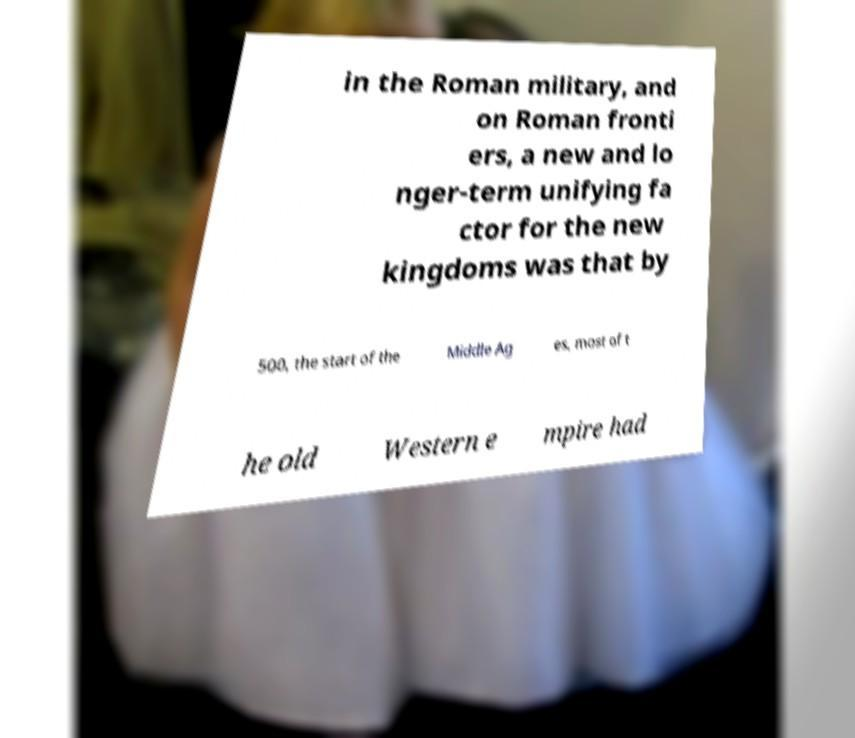Please identify and transcribe the text found in this image. in the Roman military, and on Roman fronti ers, a new and lo nger-term unifying fa ctor for the new kingdoms was that by 500, the start of the Middle Ag es, most of t he old Western e mpire had 